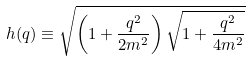Convert formula to latex. <formula><loc_0><loc_0><loc_500><loc_500>h ( q ) \equiv \sqrt { \left ( 1 + \frac { q ^ { 2 } } { 2 m ^ { 2 } } \right ) \sqrt { 1 + \frac { q ^ { 2 } } { 4 m ^ { 2 } } } }</formula> 